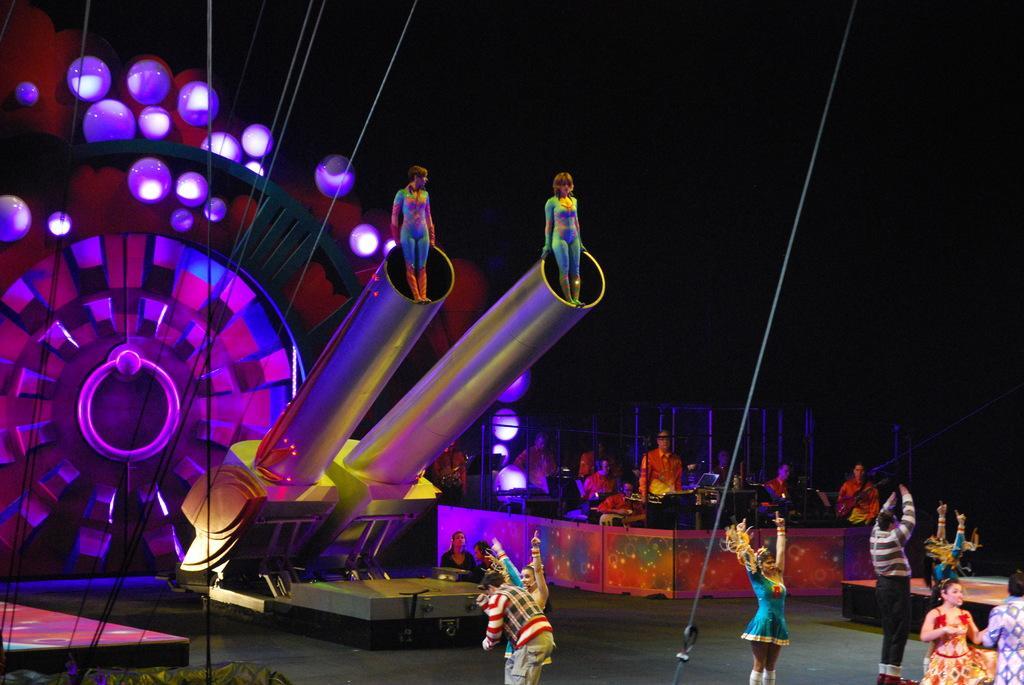Can you describe this image briefly? As we can see in the image there are few people here and there, lights, pipe and ropes. 